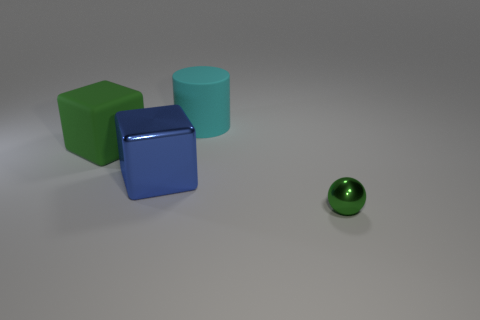What shape is the rubber object that is the same size as the cyan cylinder?
Provide a succinct answer. Cube. Are there any big things of the same color as the ball?
Ensure brevity in your answer.  Yes. There is a sphere; does it have the same color as the big matte thing to the left of the cyan matte thing?
Your response must be concise. Yes. There is a metal object that is left of the matte object right of the big blue metal object; what is its color?
Keep it short and to the point. Blue. There is a metal thing that is behind the shiny object in front of the large blue cube; is there a tiny sphere behind it?
Offer a very short reply. No. The object that is the same material as the small ball is what color?
Your answer should be compact. Blue. How many large cubes have the same material as the tiny thing?
Ensure brevity in your answer.  1. Are the cylinder and the green thing that is on the left side of the cyan object made of the same material?
Provide a short and direct response. Yes. How many things are either rubber things in front of the cyan cylinder or red shiny cylinders?
Your answer should be very brief. 1. There is a shiny thing right of the shiny object to the left of the green thing on the right side of the cyan matte cylinder; how big is it?
Your response must be concise. Small. 